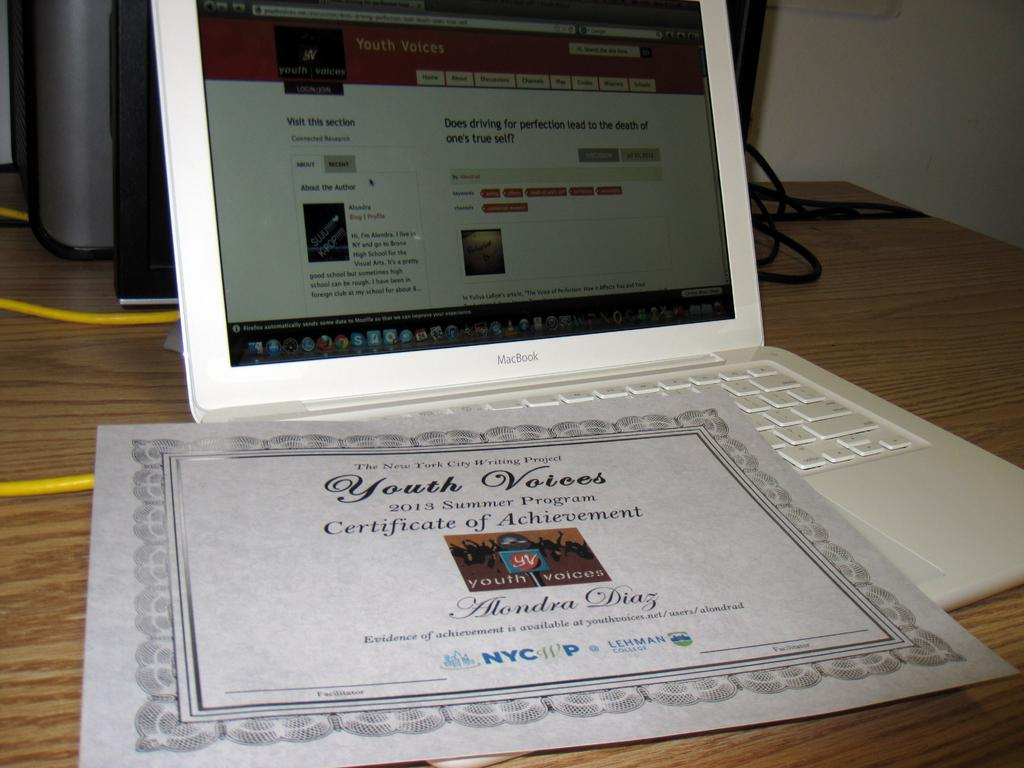Provide a one-sentence caption for the provided image. Certificate of achievement for youth voices on a white laptop. 